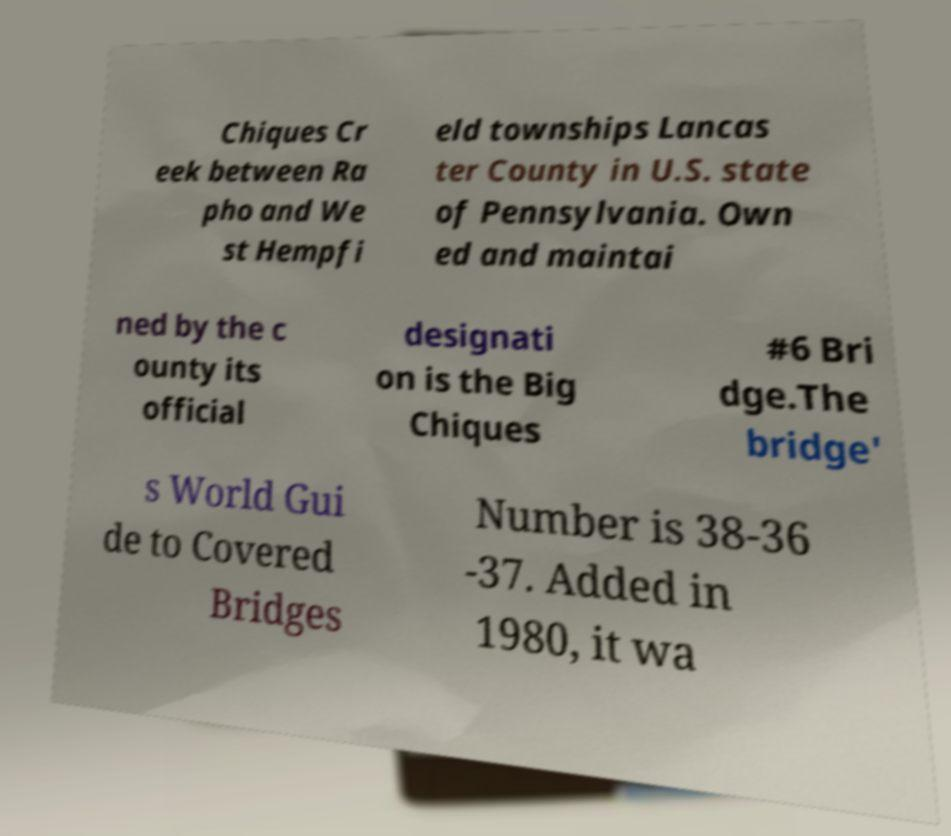I need the written content from this picture converted into text. Can you do that? Chiques Cr eek between Ra pho and We st Hempfi eld townships Lancas ter County in U.S. state of Pennsylvania. Own ed and maintai ned by the c ounty its official designati on is the Big Chiques #6 Bri dge.The bridge' s World Gui de to Covered Bridges Number is 38-36 -37. Added in 1980, it wa 